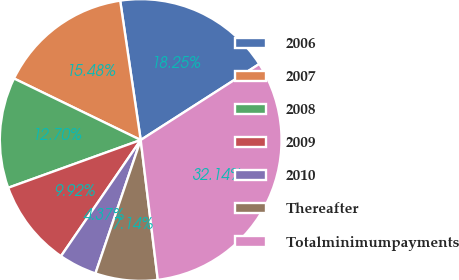<chart> <loc_0><loc_0><loc_500><loc_500><pie_chart><fcel>2006<fcel>2007<fcel>2008<fcel>2009<fcel>2010<fcel>Thereafter<fcel>Totalminimumpayments<nl><fcel>18.25%<fcel>15.48%<fcel>12.7%<fcel>9.92%<fcel>4.37%<fcel>7.14%<fcel>32.14%<nl></chart> 